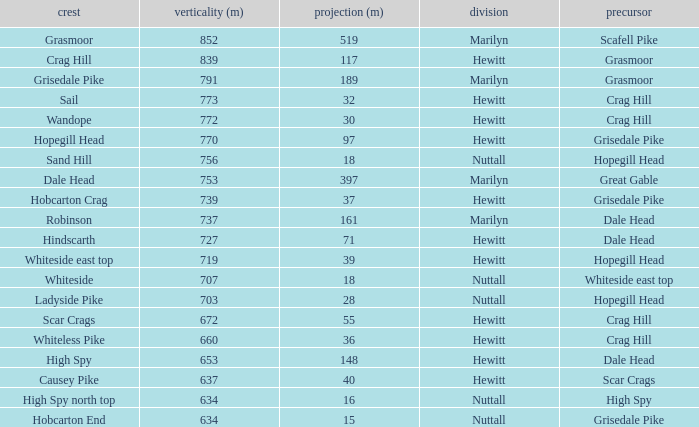Would you mind parsing the complete table? {'header': ['crest', 'verticality (m)', 'projection (m)', 'division', 'precursor'], 'rows': [['Grasmoor', '852', '519', 'Marilyn', 'Scafell Pike'], ['Crag Hill', '839', '117', 'Hewitt', 'Grasmoor'], ['Grisedale Pike', '791', '189', 'Marilyn', 'Grasmoor'], ['Sail', '773', '32', 'Hewitt', 'Crag Hill'], ['Wandope', '772', '30', 'Hewitt', 'Crag Hill'], ['Hopegill Head', '770', '97', 'Hewitt', 'Grisedale Pike'], ['Sand Hill', '756', '18', 'Nuttall', 'Hopegill Head'], ['Dale Head', '753', '397', 'Marilyn', 'Great Gable'], ['Hobcarton Crag', '739', '37', 'Hewitt', 'Grisedale Pike'], ['Robinson', '737', '161', 'Marilyn', 'Dale Head'], ['Hindscarth', '727', '71', 'Hewitt', 'Dale Head'], ['Whiteside east top', '719', '39', 'Hewitt', 'Hopegill Head'], ['Whiteside', '707', '18', 'Nuttall', 'Whiteside east top'], ['Ladyside Pike', '703', '28', 'Nuttall', 'Hopegill Head'], ['Scar Crags', '672', '55', 'Hewitt', 'Crag Hill'], ['Whiteless Pike', '660', '36', 'Hewitt', 'Crag Hill'], ['High Spy', '653', '148', 'Hewitt', 'Dale Head'], ['Causey Pike', '637', '40', 'Hewitt', 'Scar Crags'], ['High Spy north top', '634', '16', 'Nuttall', 'High Spy'], ['Hobcarton End', '634', '15', 'Nuttall', 'Grisedale Pike']]} Which Class is Peak Sail when it has a Prom larger than 30? Hewitt. 